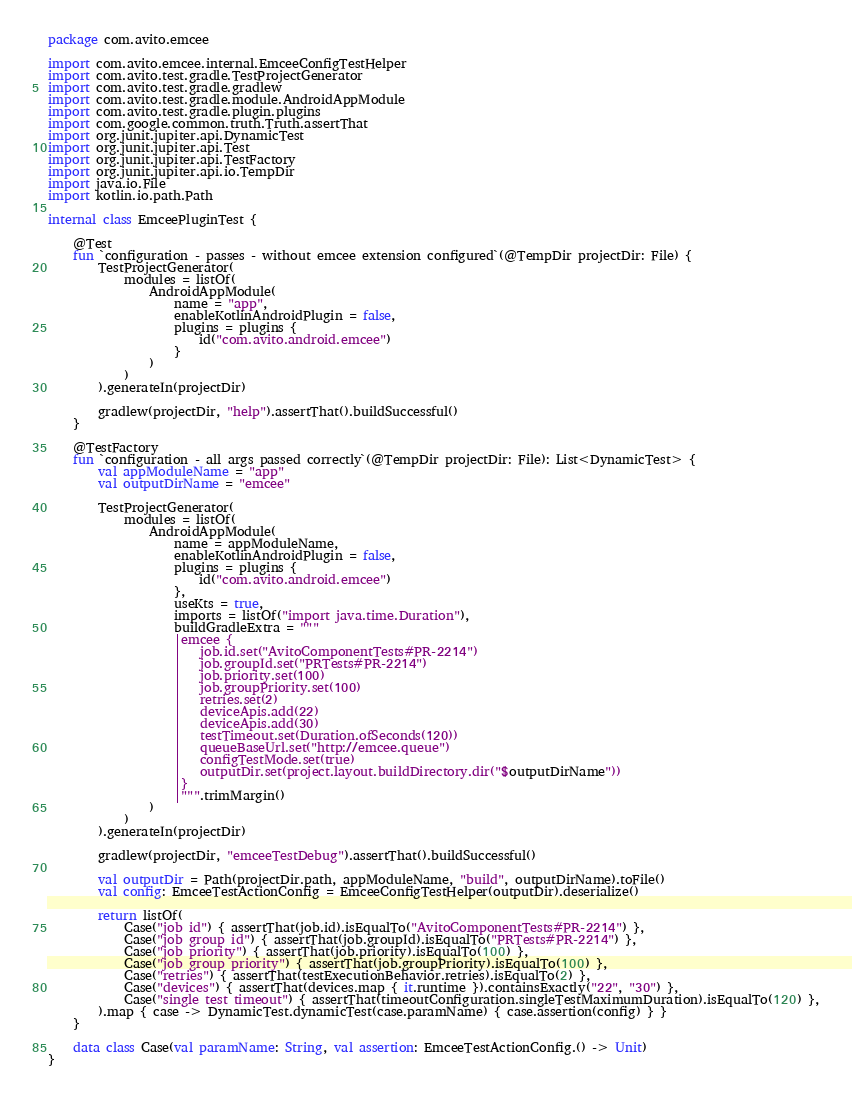<code> <loc_0><loc_0><loc_500><loc_500><_Kotlin_>package com.avito.emcee

import com.avito.emcee.internal.EmceeConfigTestHelper
import com.avito.test.gradle.TestProjectGenerator
import com.avito.test.gradle.gradlew
import com.avito.test.gradle.module.AndroidAppModule
import com.avito.test.gradle.plugin.plugins
import com.google.common.truth.Truth.assertThat
import org.junit.jupiter.api.DynamicTest
import org.junit.jupiter.api.Test
import org.junit.jupiter.api.TestFactory
import org.junit.jupiter.api.io.TempDir
import java.io.File
import kotlin.io.path.Path

internal class EmceePluginTest {

    @Test
    fun `configuration - passes - without emcee extension configured`(@TempDir projectDir: File) {
        TestProjectGenerator(
            modules = listOf(
                AndroidAppModule(
                    name = "app",
                    enableKotlinAndroidPlugin = false,
                    plugins = plugins {
                        id("com.avito.android.emcee")
                    }
                )
            )
        ).generateIn(projectDir)

        gradlew(projectDir, "help").assertThat().buildSuccessful()
    }

    @TestFactory
    fun `configuration - all args passed correctly`(@TempDir projectDir: File): List<DynamicTest> {
        val appModuleName = "app"
        val outputDirName = "emcee"

        TestProjectGenerator(
            modules = listOf(
                AndroidAppModule(
                    name = appModuleName,
                    enableKotlinAndroidPlugin = false,
                    plugins = plugins {
                        id("com.avito.android.emcee")
                    },
                    useKts = true,
                    imports = listOf("import java.time.Duration"),
                    buildGradleExtra = """
                    |emcee {
                    |   job.id.set("AvitoComponentTests#PR-2214")
                    |   job.groupId.set("PRTests#PR-2214")
                    |   job.priority.set(100)
                    |   job.groupPriority.set(100)
                    |   retries.set(2)
                    |   deviceApis.add(22)
                    |   deviceApis.add(30)
                    |   testTimeout.set(Duration.ofSeconds(120))
                    |   queueBaseUrl.set("http://emcee.queue")
                    |   configTestMode.set(true)
                    |   outputDir.set(project.layout.buildDirectory.dir("$outputDirName"))
                    |}
                    |""".trimMargin()
                )
            )
        ).generateIn(projectDir)

        gradlew(projectDir, "emceeTestDebug").assertThat().buildSuccessful()

        val outputDir = Path(projectDir.path, appModuleName, "build", outputDirName).toFile()
        val config: EmceeTestActionConfig = EmceeConfigTestHelper(outputDir).deserialize()

        return listOf(
            Case("job id") { assertThat(job.id).isEqualTo("AvitoComponentTests#PR-2214") },
            Case("job group id") { assertThat(job.groupId).isEqualTo("PRTests#PR-2214") },
            Case("job priority") { assertThat(job.priority).isEqualTo(100) },
            Case("job group priority") { assertThat(job.groupPriority).isEqualTo(100) },
            Case("retries") { assertThat(testExecutionBehavior.retries).isEqualTo(2) },
            Case("devices") { assertThat(devices.map { it.runtime }).containsExactly("22", "30") },
            Case("single test timeout") { assertThat(timeoutConfiguration.singleTestMaximumDuration).isEqualTo(120) },
        ).map { case -> DynamicTest.dynamicTest(case.paramName) { case.assertion(config) } }
    }

    data class Case(val paramName: String, val assertion: EmceeTestActionConfig.() -> Unit)
}
</code> 